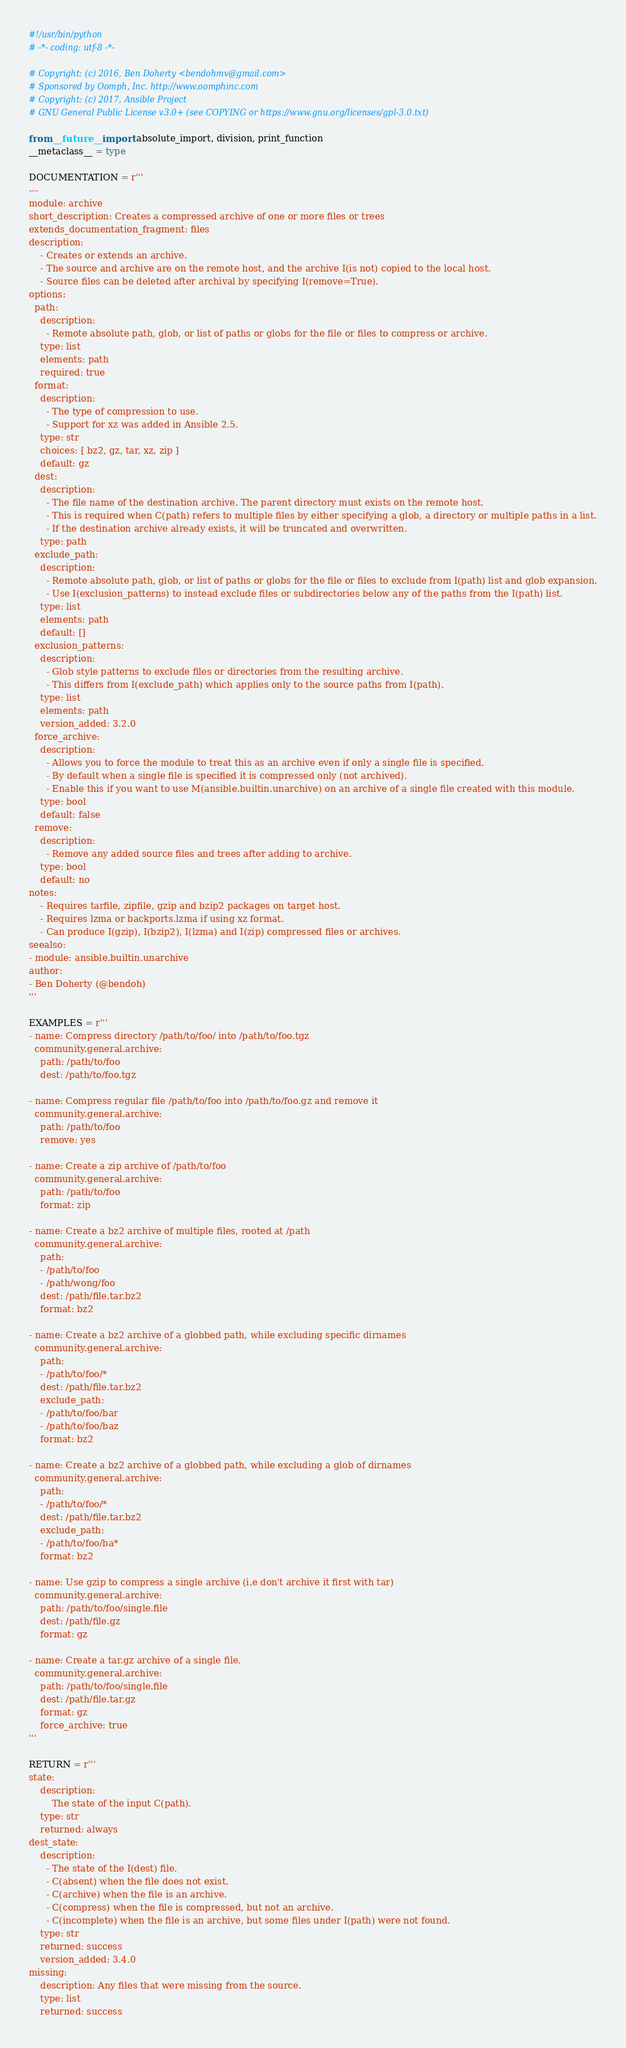<code> <loc_0><loc_0><loc_500><loc_500><_Python_>#!/usr/bin/python
# -*- coding: utf-8 -*-

# Copyright: (c) 2016, Ben Doherty <bendohmv@gmail.com>
# Sponsored by Oomph, Inc. http://www.oomphinc.com
# Copyright: (c) 2017, Ansible Project
# GNU General Public License v3.0+ (see COPYING or https://www.gnu.org/licenses/gpl-3.0.txt)

from __future__ import absolute_import, division, print_function
__metaclass__ = type

DOCUMENTATION = r'''
---
module: archive
short_description: Creates a compressed archive of one or more files or trees
extends_documentation_fragment: files
description:
    - Creates or extends an archive.
    - The source and archive are on the remote host, and the archive I(is not) copied to the local host.
    - Source files can be deleted after archival by specifying I(remove=True).
options:
  path:
    description:
      - Remote absolute path, glob, or list of paths or globs for the file or files to compress or archive.
    type: list
    elements: path
    required: true
  format:
    description:
      - The type of compression to use.
      - Support for xz was added in Ansible 2.5.
    type: str
    choices: [ bz2, gz, tar, xz, zip ]
    default: gz
  dest:
    description:
      - The file name of the destination archive. The parent directory must exists on the remote host.
      - This is required when C(path) refers to multiple files by either specifying a glob, a directory or multiple paths in a list.
      - If the destination archive already exists, it will be truncated and overwritten.
    type: path
  exclude_path:
    description:
      - Remote absolute path, glob, or list of paths or globs for the file or files to exclude from I(path) list and glob expansion.
      - Use I(exclusion_patterns) to instead exclude files or subdirectories below any of the paths from the I(path) list.
    type: list
    elements: path
    default: []
  exclusion_patterns:
    description:
      - Glob style patterns to exclude files or directories from the resulting archive.
      - This differs from I(exclude_path) which applies only to the source paths from I(path).
    type: list
    elements: path
    version_added: 3.2.0
  force_archive:
    description:
      - Allows you to force the module to treat this as an archive even if only a single file is specified.
      - By default when a single file is specified it is compressed only (not archived).
      - Enable this if you want to use M(ansible.builtin.unarchive) on an archive of a single file created with this module.
    type: bool
    default: false
  remove:
    description:
      - Remove any added source files and trees after adding to archive.
    type: bool
    default: no
notes:
    - Requires tarfile, zipfile, gzip and bzip2 packages on target host.
    - Requires lzma or backports.lzma if using xz format.
    - Can produce I(gzip), I(bzip2), I(lzma) and I(zip) compressed files or archives.
seealso:
- module: ansible.builtin.unarchive
author:
- Ben Doherty (@bendoh)
'''

EXAMPLES = r'''
- name: Compress directory /path/to/foo/ into /path/to/foo.tgz
  community.general.archive:
    path: /path/to/foo
    dest: /path/to/foo.tgz

- name: Compress regular file /path/to/foo into /path/to/foo.gz and remove it
  community.general.archive:
    path: /path/to/foo
    remove: yes

- name: Create a zip archive of /path/to/foo
  community.general.archive:
    path: /path/to/foo
    format: zip

- name: Create a bz2 archive of multiple files, rooted at /path
  community.general.archive:
    path:
    - /path/to/foo
    - /path/wong/foo
    dest: /path/file.tar.bz2
    format: bz2

- name: Create a bz2 archive of a globbed path, while excluding specific dirnames
  community.general.archive:
    path:
    - /path/to/foo/*
    dest: /path/file.tar.bz2
    exclude_path:
    - /path/to/foo/bar
    - /path/to/foo/baz
    format: bz2

- name: Create a bz2 archive of a globbed path, while excluding a glob of dirnames
  community.general.archive:
    path:
    - /path/to/foo/*
    dest: /path/file.tar.bz2
    exclude_path:
    - /path/to/foo/ba*
    format: bz2

- name: Use gzip to compress a single archive (i.e don't archive it first with tar)
  community.general.archive:
    path: /path/to/foo/single.file
    dest: /path/file.gz
    format: gz

- name: Create a tar.gz archive of a single file.
  community.general.archive:
    path: /path/to/foo/single.file
    dest: /path/file.tar.gz
    format: gz
    force_archive: true
'''

RETURN = r'''
state:
    description:
        The state of the input C(path).
    type: str
    returned: always
dest_state:
    description:
      - The state of the I(dest) file.
      - C(absent) when the file does not exist.
      - C(archive) when the file is an archive.
      - C(compress) when the file is compressed, but not an archive.
      - C(incomplete) when the file is an archive, but some files under I(path) were not found.
    type: str
    returned: success
    version_added: 3.4.0
missing:
    description: Any files that were missing from the source.
    type: list
    returned: success</code> 